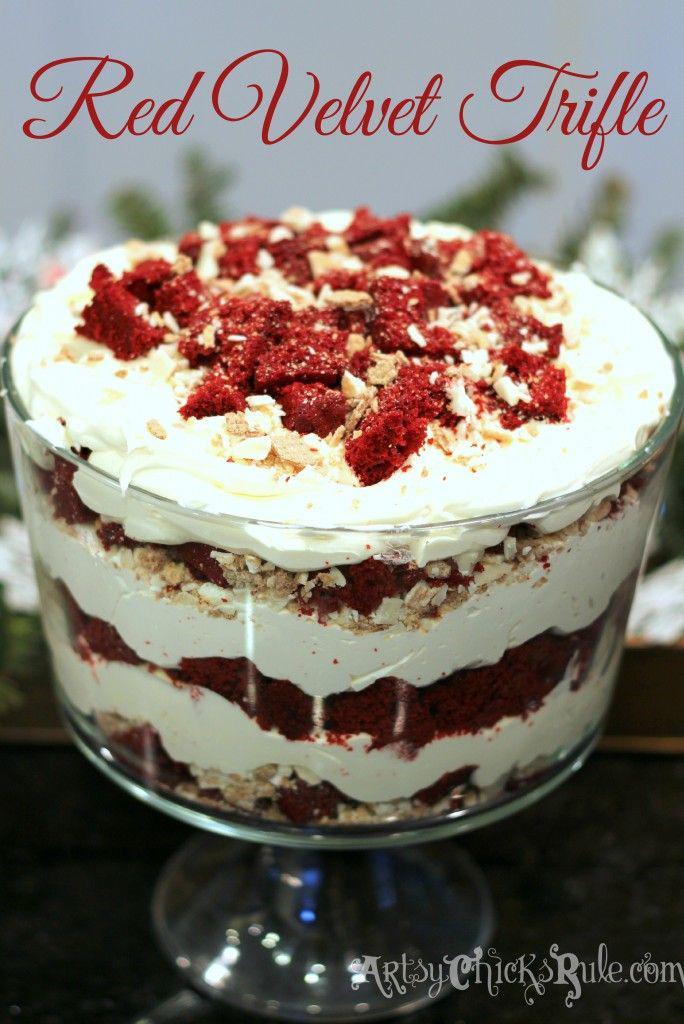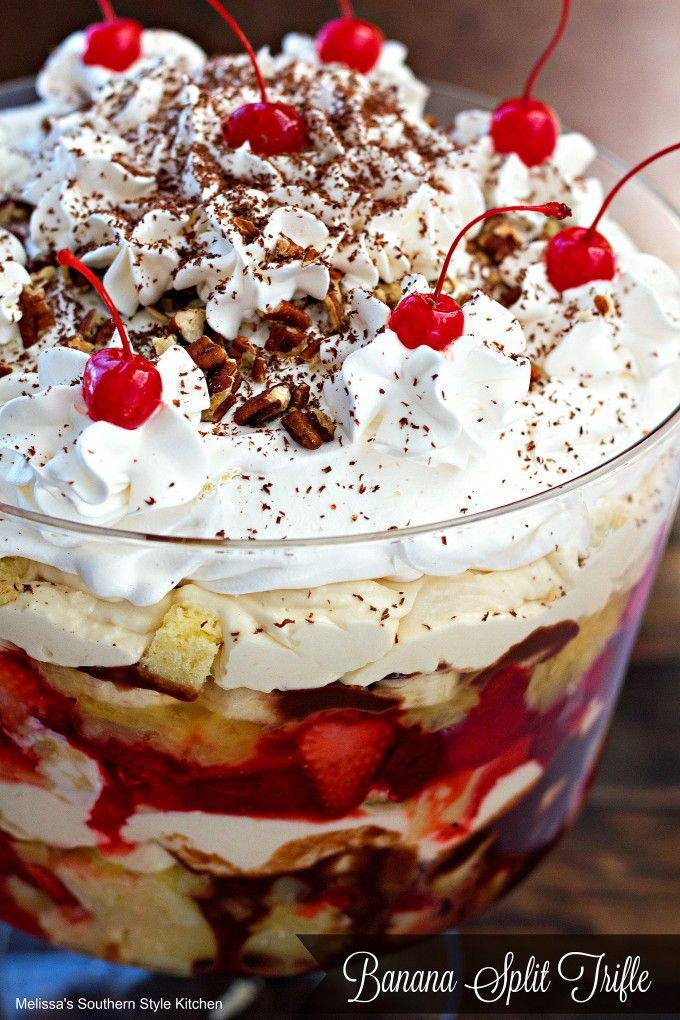The first image is the image on the left, the second image is the image on the right. Given the left and right images, does the statement "There is at least one cherry with a stem in the image on the right." hold true? Answer yes or no. Yes. The first image is the image on the left, the second image is the image on the right. Considering the images on both sides, is "The right image shows exactly two virtually identical trifle desserts." valid? Answer yes or no. No. 